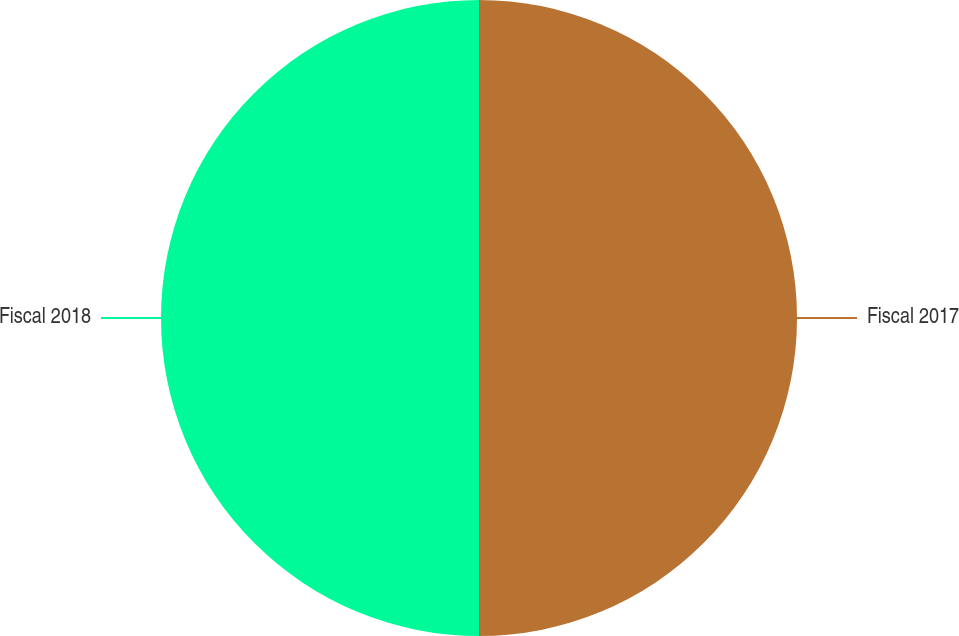Convert chart to OTSL. <chart><loc_0><loc_0><loc_500><loc_500><pie_chart><fcel>Fiscal 2017<fcel>Fiscal 2018<nl><fcel>50.0%<fcel>50.0%<nl></chart> 